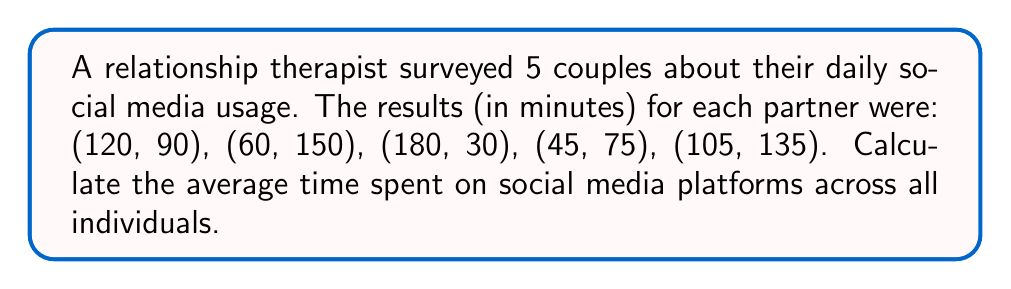Show me your answer to this math problem. To find the average time spent on social media platforms, we need to:

1. Sum up all the times:
   $120 + 90 + 60 + 150 + 180 + 30 + 45 + 75 + 105 + 135 = 990$ minutes

2. Count the total number of individuals:
   $5$ couples $\times 2$ people per couple $= 10$ individuals

3. Calculate the average using the formula:
   $\text{Average} = \frac{\text{Sum of all values}}{\text{Number of values}}$

   $$\text{Average} = \frac{990}{10} = 99$$

Therefore, the average time spent on social media platforms is 99 minutes.
Answer: 99 minutes 